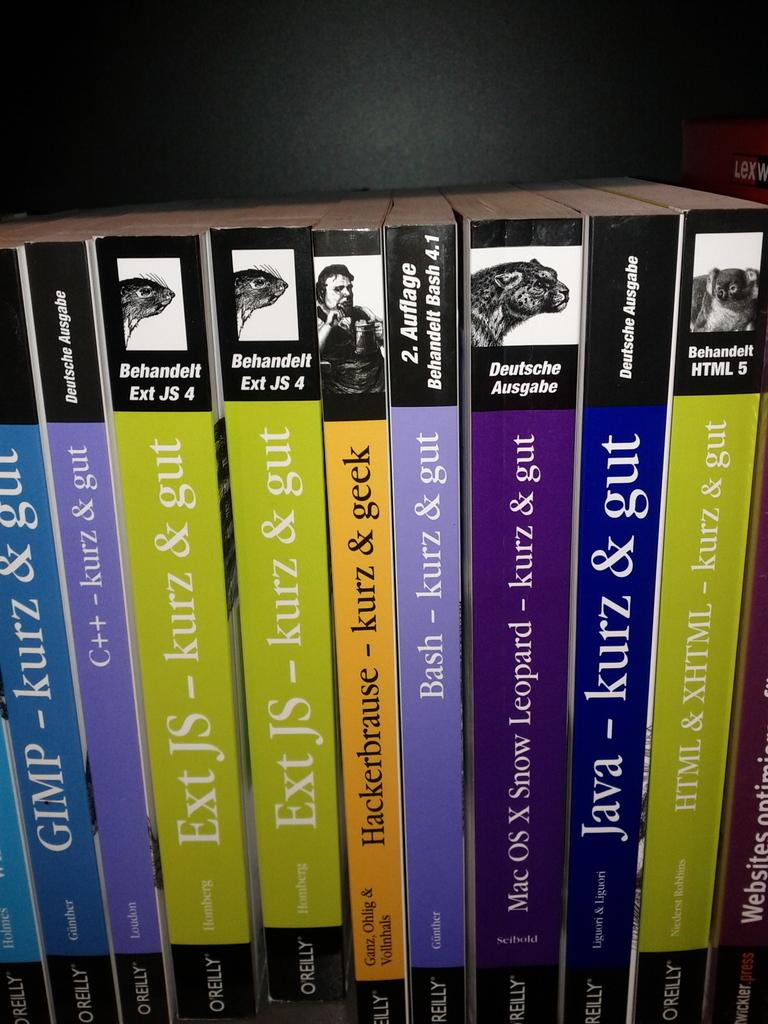Provide a one-sentence caption for the provided image. a blue book with the word java on it. 